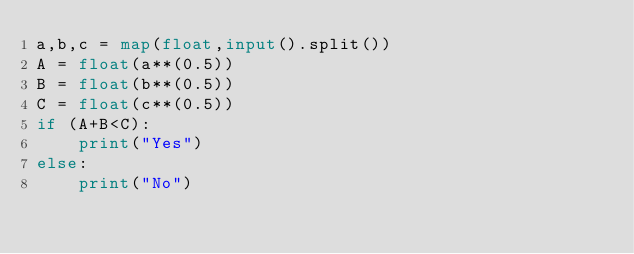<code> <loc_0><loc_0><loc_500><loc_500><_Python_>a,b,c = map(float,input().split())
A = float(a**(0.5))
B = float(b**(0.5))
C = float(c**(0.5))
if (A+B<C):
    print("Yes")
else:
    print("No")</code> 